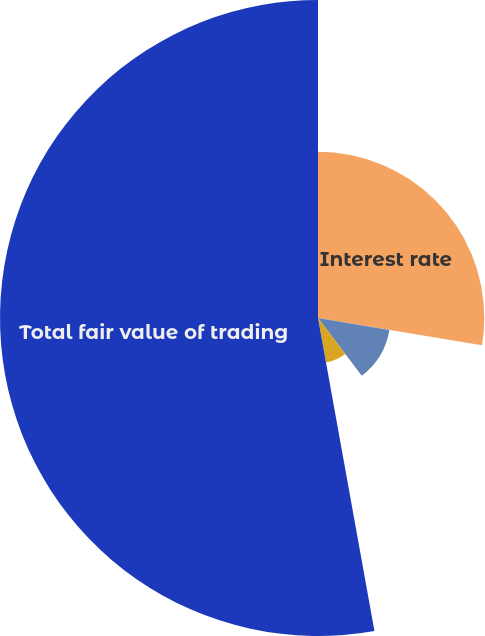<chart> <loc_0><loc_0><loc_500><loc_500><pie_chart><fcel>Interest rate<fcel>Foreign exchange (b)<fcel>Commodity<fcel>Total fair value of trading<nl><fcel>27.63%<fcel>12.03%<fcel>7.5%<fcel>52.84%<nl></chart> 